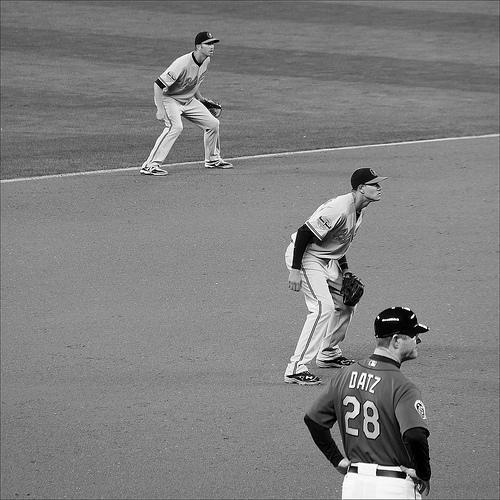How many players are shown?
Give a very brief answer. 3. How many teams are represented?
Give a very brief answer. 2. 